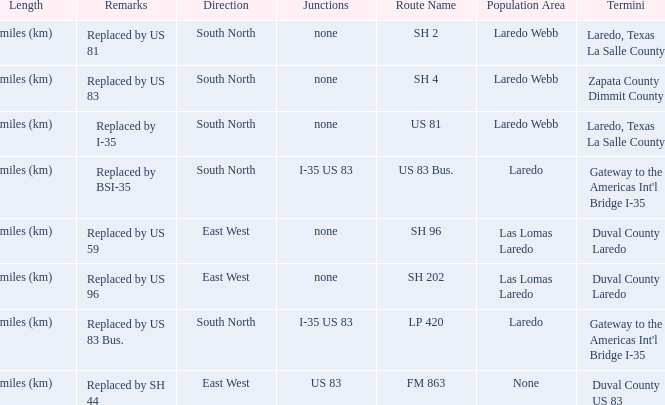Help me parse the entirety of this table. {'header': ['Length', 'Remarks', 'Direction', 'Junctions', 'Route Name', 'Population Area', 'Termini'], 'rows': [['miles (km)', 'Replaced by US 81', 'South North', 'none', 'SH 2', 'Laredo Webb', 'Laredo, Texas La Salle County'], ['miles (km)', 'Replaced by US 83', 'South North', 'none', 'SH 4', 'Laredo Webb', 'Zapata County Dimmit County'], ['miles (km)', 'Replaced by I-35', 'South North', 'none', 'US 81', 'Laredo Webb', 'Laredo, Texas La Salle County'], ['miles (km)', 'Replaced by BSI-35', 'South North', 'I-35 US 83', 'US 83 Bus.', 'Laredo', "Gateway to the Americas Int'l Bridge I-35"], ['miles (km)', 'Replaced by US 59', 'East West', 'none', 'SH 96', 'Las Lomas Laredo', 'Duval County Laredo'], ['miles (km)', 'Replaced by US 96', 'East West', 'none', 'SH 202', 'Las Lomas Laredo', 'Duval County Laredo'], ['miles (km)', 'Replaced by US 83 Bus.', 'South North', 'I-35 US 83', 'LP 420', 'Laredo', "Gateway to the Americas Int'l Bridge I-35"], ['miles (km)', 'Replaced by SH 44', 'East West', 'US 83', 'FM 863', 'None', 'Duval County US 83']]} Which routes have  "replaced by US 81" listed in their remarks section? SH 2. 